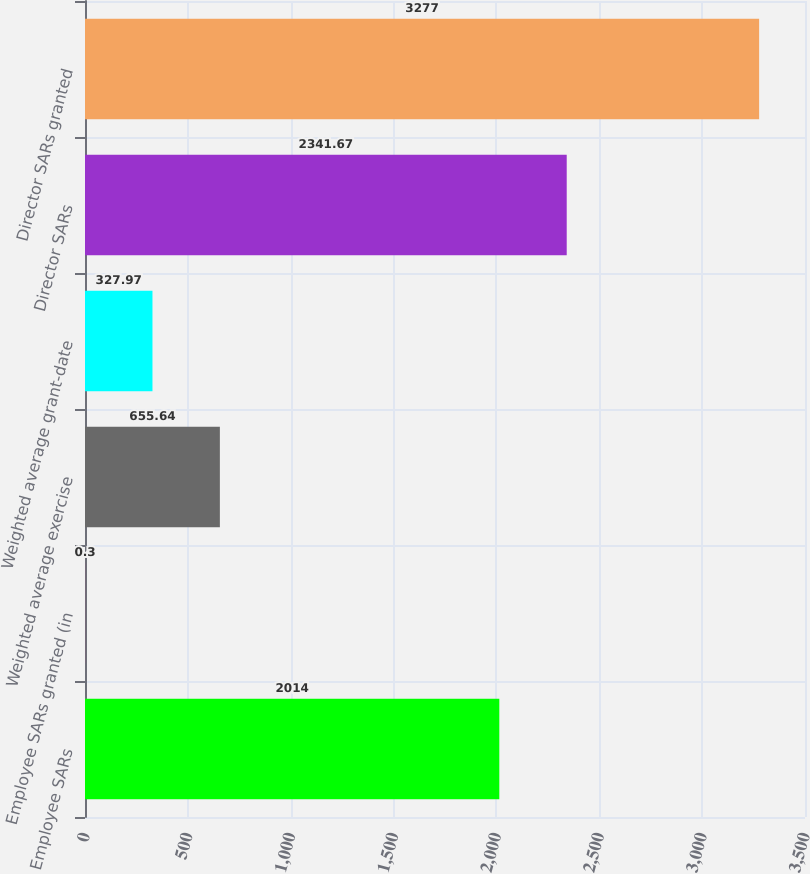<chart> <loc_0><loc_0><loc_500><loc_500><bar_chart><fcel>Employee SARs<fcel>Employee SARs granted (in<fcel>Weighted average exercise<fcel>Weighted average grant-date<fcel>Director SARs<fcel>Director SARs granted<nl><fcel>2014<fcel>0.3<fcel>655.64<fcel>327.97<fcel>2341.67<fcel>3277<nl></chart> 